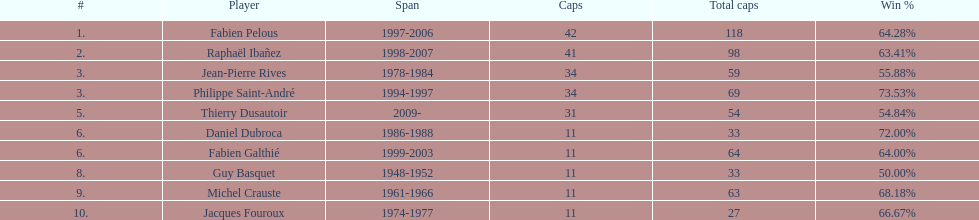How many players have spans above three years? 6. 